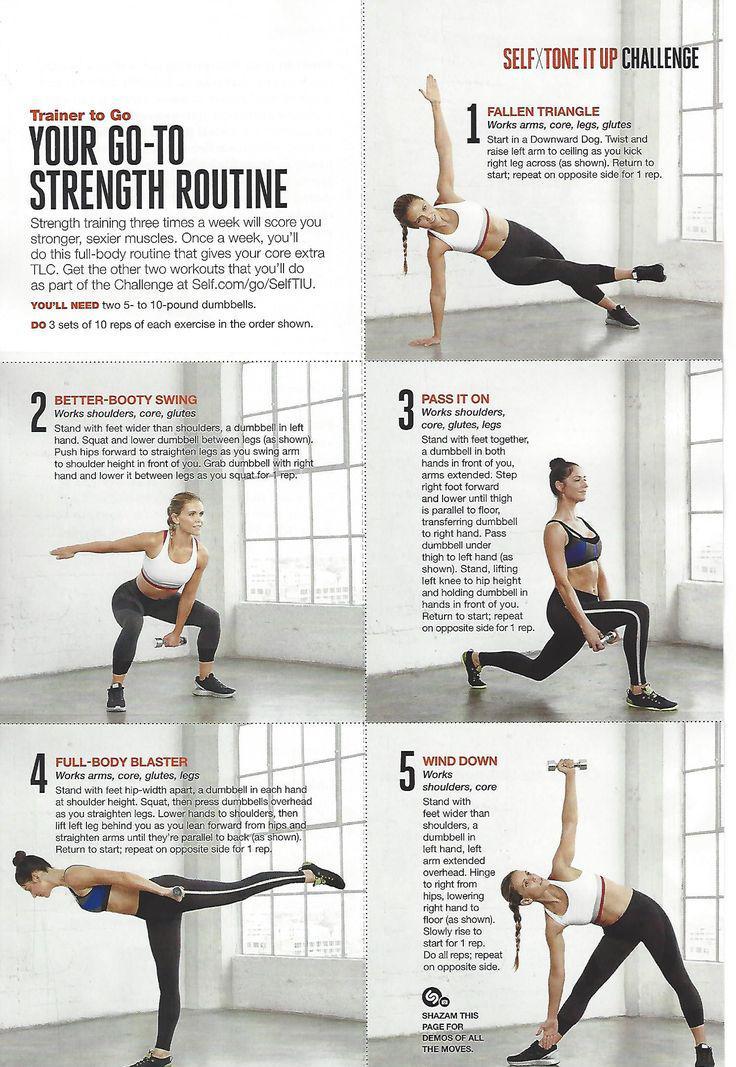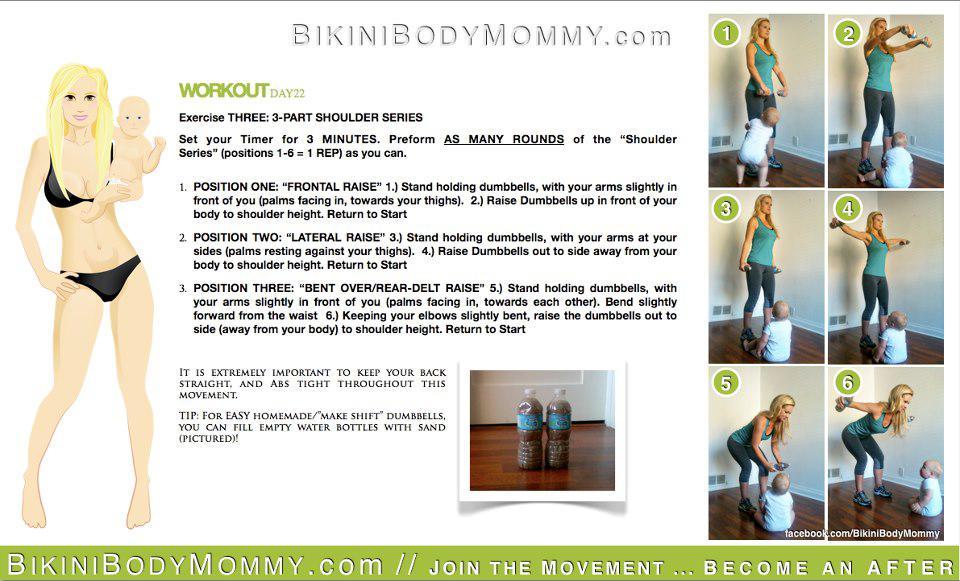The first image is the image on the left, the second image is the image on the right. Evaluate the accuracy of this statement regarding the images: "In one of the images there are three dumbbells of varying sizes arranged in a line.". Is it true? Answer yes or no. No. 